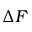<formula> <loc_0><loc_0><loc_500><loc_500>\Delta F</formula> 